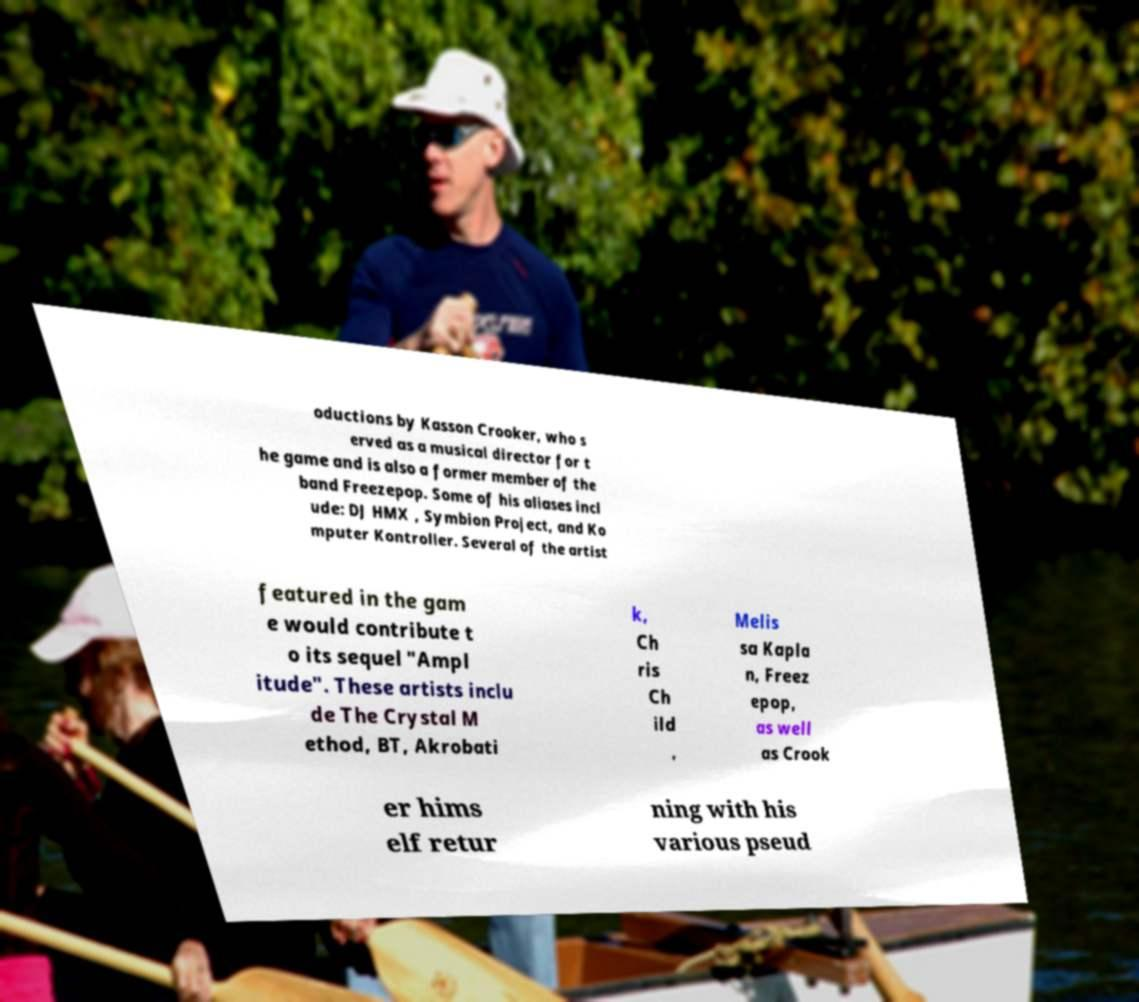Can you read and provide the text displayed in the image?This photo seems to have some interesting text. Can you extract and type it out for me? oductions by Kasson Crooker, who s erved as a musical director for t he game and is also a former member of the band Freezepop. Some of his aliases incl ude: DJ HMX , Symbion Project, and Ko mputer Kontroller. Several of the artist featured in the gam e would contribute t o its sequel "Ampl itude". These artists inclu de The Crystal M ethod, BT, Akrobati k, Ch ris Ch ild , Melis sa Kapla n, Freez epop, as well as Crook er hims elf retur ning with his various pseud 